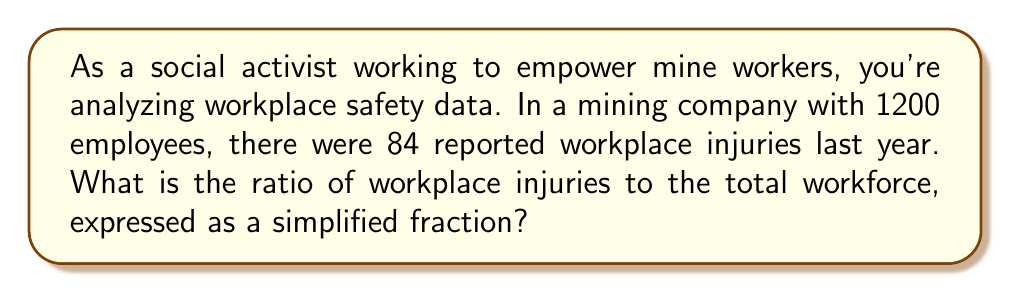What is the answer to this math problem? To solve this problem, we need to follow these steps:

1. Identify the given information:
   - Total workforce: 1200 employees
   - Number of workplace injuries: 84

2. Set up the ratio:
   $\text{Ratio} = \frac{\text{Number of workplace injuries}}{\text{Total workforce}}$

3. Substitute the values:
   $\text{Ratio} = \frac{84}{1200}$

4. Simplify the fraction:
   To simplify, we need to find the greatest common divisor (GCD) of 84 and 1200.
   
   Factors of 84: 1, 2, 3, 4, 6, 7, 12, 14, 21, 28, 42, 84
   Factors of 1200: 1, 2, 3, 4, 5, 6, 8, 10, 12, 15, 16, 20, 24, 25, 30, 40, 48, 50, 60, 75, 80, 100, 120, 150, 200, 240, 300, 400, 600, 1200

   The greatest common divisor is 12.

5. Divide both the numerator and denominator by the GCD:
   $$\frac{84 \div 12}{1200 \div 12} = \frac{7}{100}$$

Therefore, the simplified ratio of workplace injuries to the total workforce is 7:100.
Answer: $\frac{7}{100}$ or 7:100 